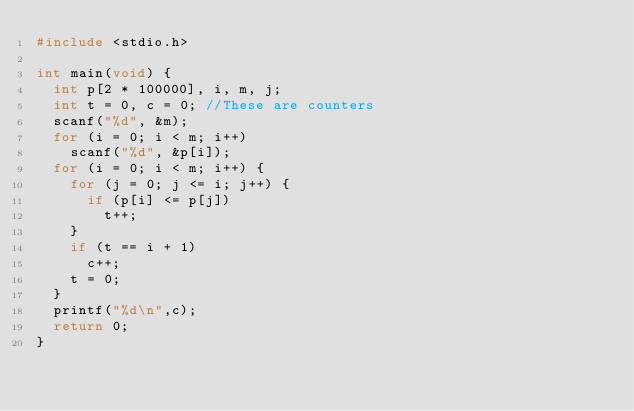Convert code to text. <code><loc_0><loc_0><loc_500><loc_500><_C_>#include <stdio.h>

int main(void) {
  int p[2 * 100000], i, m, j;
  int t = 0, c = 0; //These are counters
  scanf("%d", &m);
  for (i = 0; i < m; i++)
    scanf("%d", &p[i]);
  for (i = 0; i < m; i++) {
    for (j = 0; j <= i; j++) {
      if (p[i] <= p[j])
        t++;
    }
    if (t == i + 1)
      c++;
    t = 0;
  }
  printf("%d\n",c);
  return 0;
}</code> 